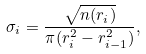Convert formula to latex. <formula><loc_0><loc_0><loc_500><loc_500>\sigma _ { i } = \frac { \sqrt { n ( r _ { i } ) } } { \pi ( r _ { i } ^ { 2 } - r _ { i - 1 } ^ { 2 } ) } ,</formula> 